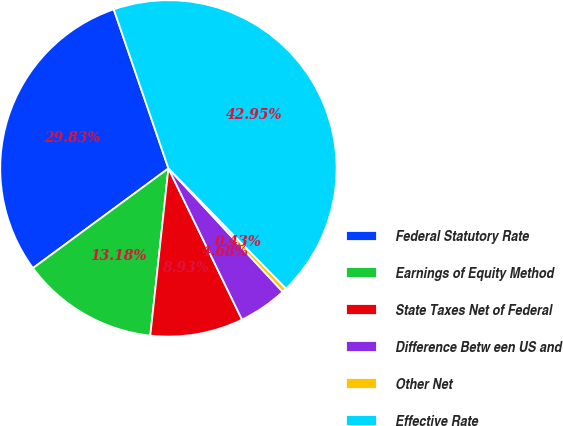Convert chart to OTSL. <chart><loc_0><loc_0><loc_500><loc_500><pie_chart><fcel>Federal Statutory Rate<fcel>Earnings of Equity Method<fcel>State Taxes Net of Federal<fcel>Difference Betw een US and<fcel>Other Net<fcel>Effective Rate<nl><fcel>29.83%<fcel>13.18%<fcel>8.93%<fcel>4.68%<fcel>0.43%<fcel>42.95%<nl></chart> 